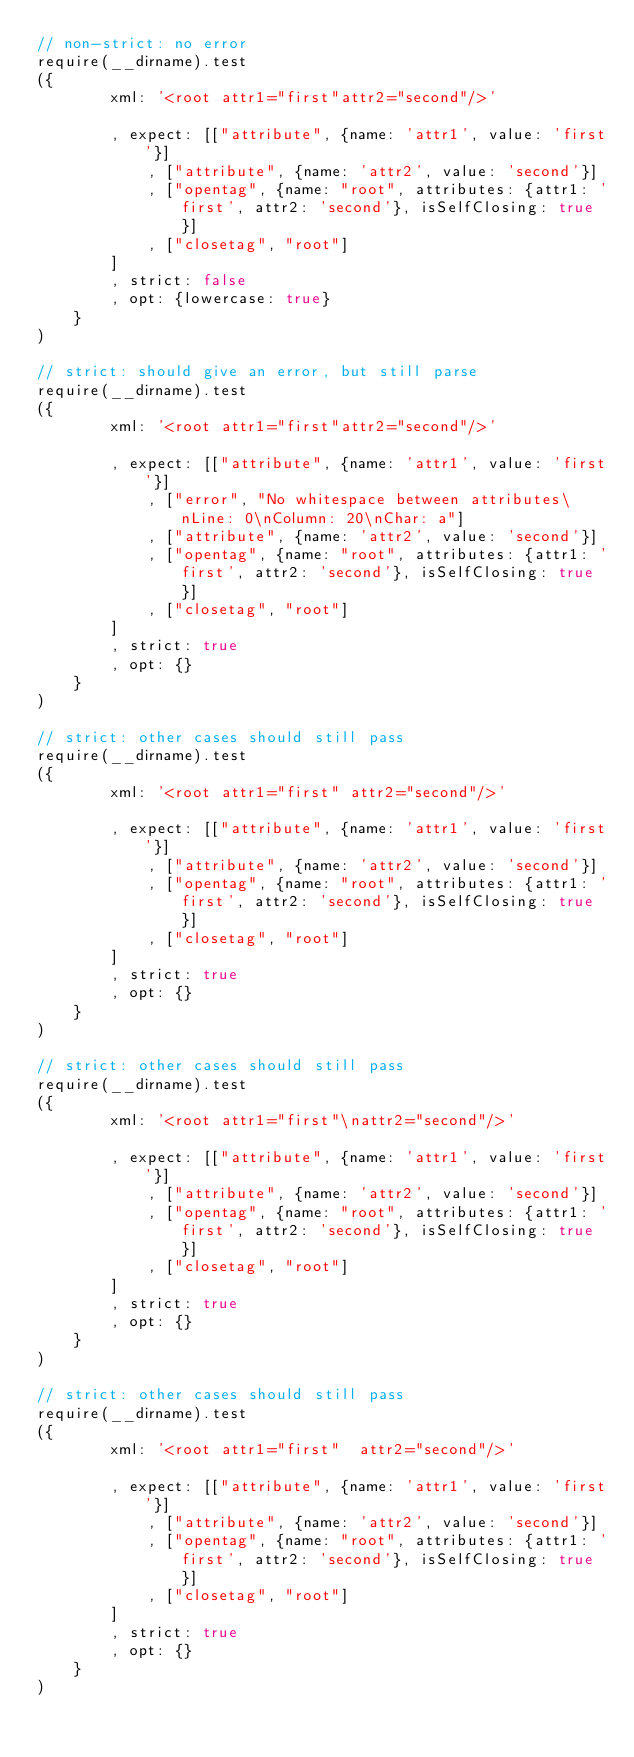Convert code to text. <code><loc_0><loc_0><loc_500><loc_500><_JavaScript_>// non-strict: no error
require(__dirname).test
({
        xml: '<root attr1="first"attr2="second"/>'

        , expect: [["attribute", {name: 'attr1', value: 'first'}]
            , ["attribute", {name: 'attr2', value: 'second'}]
            , ["opentag", {name: "root", attributes: {attr1: 'first', attr2: 'second'}, isSelfClosing: true}]
            , ["closetag", "root"]
        ]
        , strict: false
        , opt: {lowercase: true}
    }
)

// strict: should give an error, but still parse
require(__dirname).test
({
        xml: '<root attr1="first"attr2="second"/>'

        , expect: [["attribute", {name: 'attr1', value: 'first'}]
            , ["error", "No whitespace between attributes\nLine: 0\nColumn: 20\nChar: a"]
            , ["attribute", {name: 'attr2', value: 'second'}]
            , ["opentag", {name: "root", attributes: {attr1: 'first', attr2: 'second'}, isSelfClosing: true}]
            , ["closetag", "root"]
        ]
        , strict: true
        , opt: {}
    }
)

// strict: other cases should still pass
require(__dirname).test
({
        xml: '<root attr1="first" attr2="second"/>'

        , expect: [["attribute", {name: 'attr1', value: 'first'}]
            , ["attribute", {name: 'attr2', value: 'second'}]
            , ["opentag", {name: "root", attributes: {attr1: 'first', attr2: 'second'}, isSelfClosing: true}]
            , ["closetag", "root"]
        ]
        , strict: true
        , opt: {}
    }
)

// strict: other cases should still pass
require(__dirname).test
({
        xml: '<root attr1="first"\nattr2="second"/>'

        , expect: [["attribute", {name: 'attr1', value: 'first'}]
            , ["attribute", {name: 'attr2', value: 'second'}]
            , ["opentag", {name: "root", attributes: {attr1: 'first', attr2: 'second'}, isSelfClosing: true}]
            , ["closetag", "root"]
        ]
        , strict: true
        , opt: {}
    }
)

// strict: other cases should still pass
require(__dirname).test
({
        xml: '<root attr1="first"  attr2="second"/>'

        , expect: [["attribute", {name: 'attr1', value: 'first'}]
            , ["attribute", {name: 'attr2', value: 'second'}]
            , ["opentag", {name: "root", attributes: {attr1: 'first', attr2: 'second'}, isSelfClosing: true}]
            , ["closetag", "root"]
        ]
        , strict: true
        , opt: {}
    }
)
</code> 